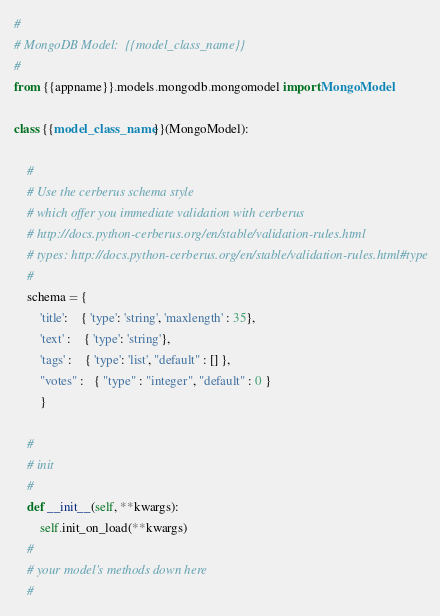<code> <loc_0><loc_0><loc_500><loc_500><_Python_>#
# MongoDB Model:  {{model_class_name}}
#
from {{appname}}.models.mongodb.mongomodel import MongoModel

class {{model_class_name}}(MongoModel):

    #
    # Use the cerberus schema style 
    # which offer you immediate validation with cerberus
    # http://docs.python-cerberus.org/en/stable/validation-rules.html
    # types: http://docs.python-cerberus.org/en/stable/validation-rules.html#type
    #
    schema = {
        'title':    { 'type': 'string', 'maxlength' : 35},
        'text' :    { 'type': 'string'},
        'tags' :    { 'type': 'list', "default" : [] },
        "votes" :   { "type" : "integer", "default" : 0 }   
        }

    #
    # init
    #
    def __init__(self, **kwargs):
        self.init_on_load(**kwargs)
    #
    # your model's methods down here
    #
</code> 